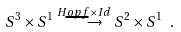Convert formula to latex. <formula><loc_0><loc_0><loc_500><loc_500>S ^ { 3 } \times S ^ { 1 } \stackrel { H o p f \times I d } { \longrightarrow } S ^ { 2 } \times S ^ { 1 } \ .</formula> 